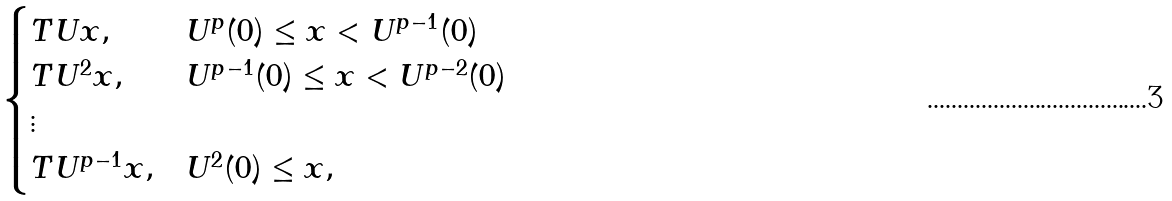Convert formula to latex. <formula><loc_0><loc_0><loc_500><loc_500>\begin{cases} T U x , & U ^ { p } ( 0 ) \leq x < U ^ { p - 1 } ( 0 ) \\ T U ^ { 2 } x , & U ^ { p - 1 } ( 0 ) \leq x < U ^ { p - 2 } ( 0 ) \\ \vdots \\ T U ^ { p - 1 } x , & U ^ { 2 } ( 0 ) \leq x , \end{cases}</formula> 